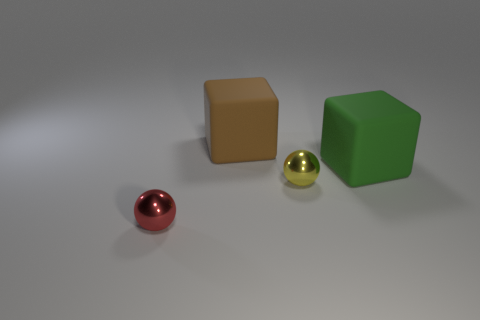How many green cubes are the same size as the green matte object?
Your response must be concise. 0. Is the material of the thing on the right side of the small yellow thing the same as the small red sphere?
Offer a terse response. No. Is there a tiny green metallic thing?
Offer a very short reply. No. What is the size of the brown thing that is made of the same material as the big green thing?
Give a very brief answer. Large. Is there a small green block made of the same material as the big brown block?
Your answer should be compact. No. What is the size of the rubber object in front of the object that is behind the big matte object that is right of the brown object?
Provide a short and direct response. Large. What number of other objects are the same shape as the big green thing?
Your answer should be very brief. 1. The object that is both behind the yellow ball and right of the big brown block is what color?
Your answer should be very brief. Green. How many blocks are either brown things or metal objects?
Your answer should be very brief. 1. What is the shape of the metal thing that is right of the big brown object?
Offer a very short reply. Sphere. 